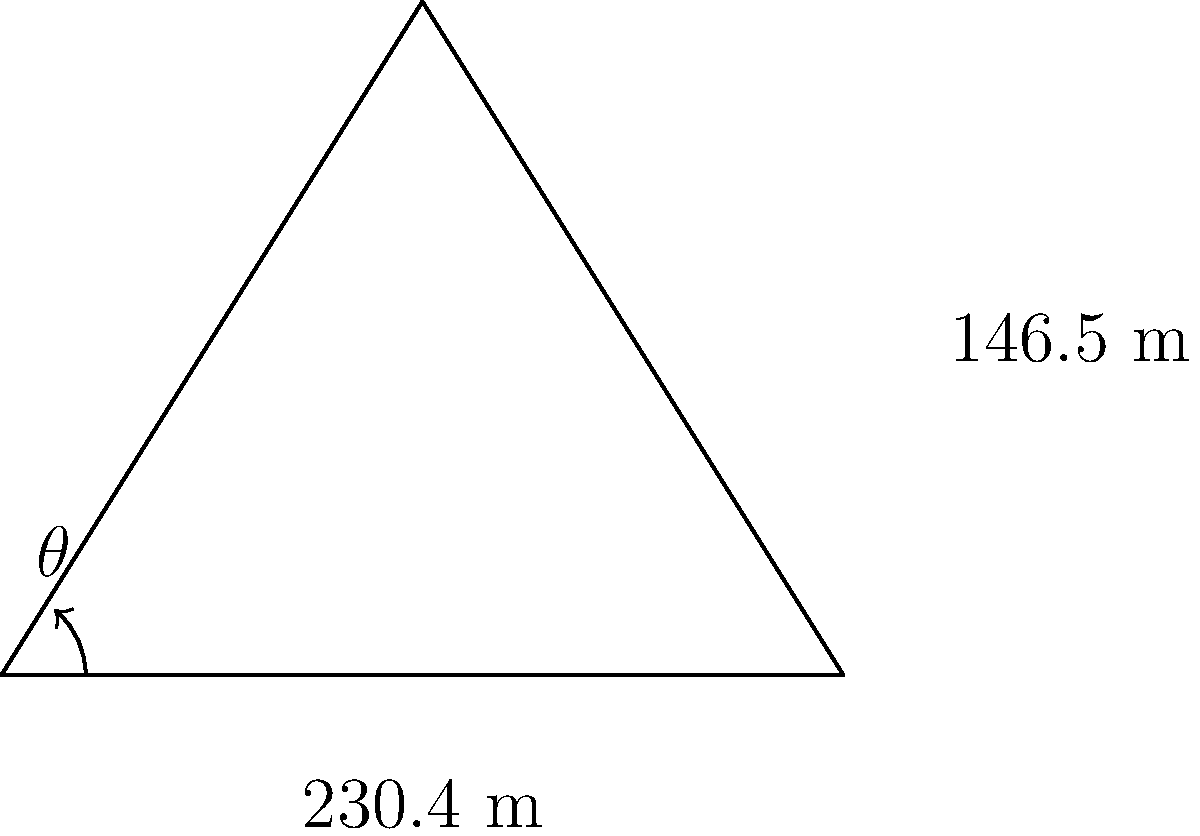Given that the base length of the Great Pyramid of Giza is 230.4 meters and its height is 146.5 meters, what is the angle $\theta$ between the base and the sloped face, rounded to the nearest degree? To find the angle $\theta$ between the base and the sloped face of the Great Pyramid, we can use trigonometry. Let's approach this step-by-step:

1. We have a right triangle formed by:
   - The base (half of the pyramid's base length)
   - The height of the pyramid
   - The sloped face

2. The base length of the triangle is half of the pyramid's base:
   $\frac{230.4}{2} = 115.2$ meters

3. The height of the triangle is the pyramid's height:
   $146.5$ meters

4. We can use the arctangent function to find the angle:
   $\theta = \arctan(\frac{\text{opposite}}{\text{adjacent}})$

5. Substituting our values:
   $\theta = \arctan(\frac{146.5}{115.2})$

6. Calculating:
   $\theta \approx 51.84^\circ$

7. Rounding to the nearest degree:
   $\theta \approx 52^\circ$

This angle aligns with the historical accuracy of the Great Pyramid's construction, showcasing the advanced mathematical and architectural knowledge of ancient Egyptians.
Answer: $52^\circ$ 